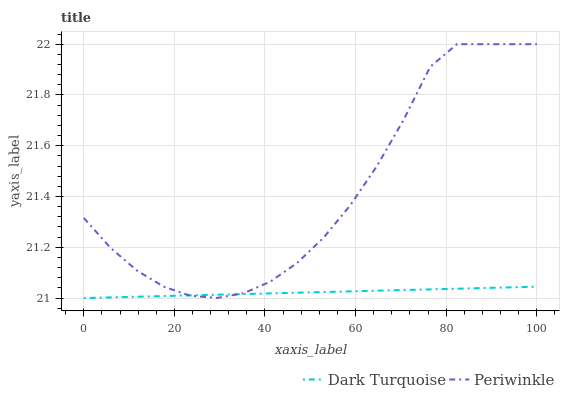Does Dark Turquoise have the minimum area under the curve?
Answer yes or no. Yes. Does Periwinkle have the maximum area under the curve?
Answer yes or no. Yes. Does Periwinkle have the minimum area under the curve?
Answer yes or no. No. Is Dark Turquoise the smoothest?
Answer yes or no. Yes. Is Periwinkle the roughest?
Answer yes or no. Yes. Is Periwinkle the smoothest?
Answer yes or no. No. Does Dark Turquoise have the lowest value?
Answer yes or no. Yes. Does Periwinkle have the lowest value?
Answer yes or no. No. Does Periwinkle have the highest value?
Answer yes or no. Yes. Does Dark Turquoise intersect Periwinkle?
Answer yes or no. Yes. Is Dark Turquoise less than Periwinkle?
Answer yes or no. No. Is Dark Turquoise greater than Periwinkle?
Answer yes or no. No. 